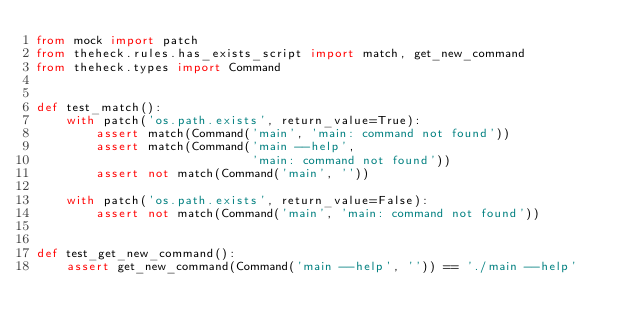<code> <loc_0><loc_0><loc_500><loc_500><_Python_>from mock import patch
from theheck.rules.has_exists_script import match, get_new_command
from theheck.types import Command


def test_match():
    with patch('os.path.exists', return_value=True):
        assert match(Command('main', 'main: command not found'))
        assert match(Command('main --help',
                             'main: command not found'))
        assert not match(Command('main', ''))

    with patch('os.path.exists', return_value=False):
        assert not match(Command('main', 'main: command not found'))


def test_get_new_command():
    assert get_new_command(Command('main --help', '')) == './main --help'
</code> 